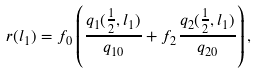Convert formula to latex. <formula><loc_0><loc_0><loc_500><loc_500>r ( l _ { 1 } ) = f _ { 0 } \left ( \frac { q _ { 1 } ( \frac { 1 } { 2 } , l _ { 1 } ) } { q _ { 1 0 } } + f _ { 2 } \frac { q _ { 2 } ( \frac { 1 } { 2 } , l _ { 1 } ) } { q _ { 2 0 } } \right ) ,</formula> 